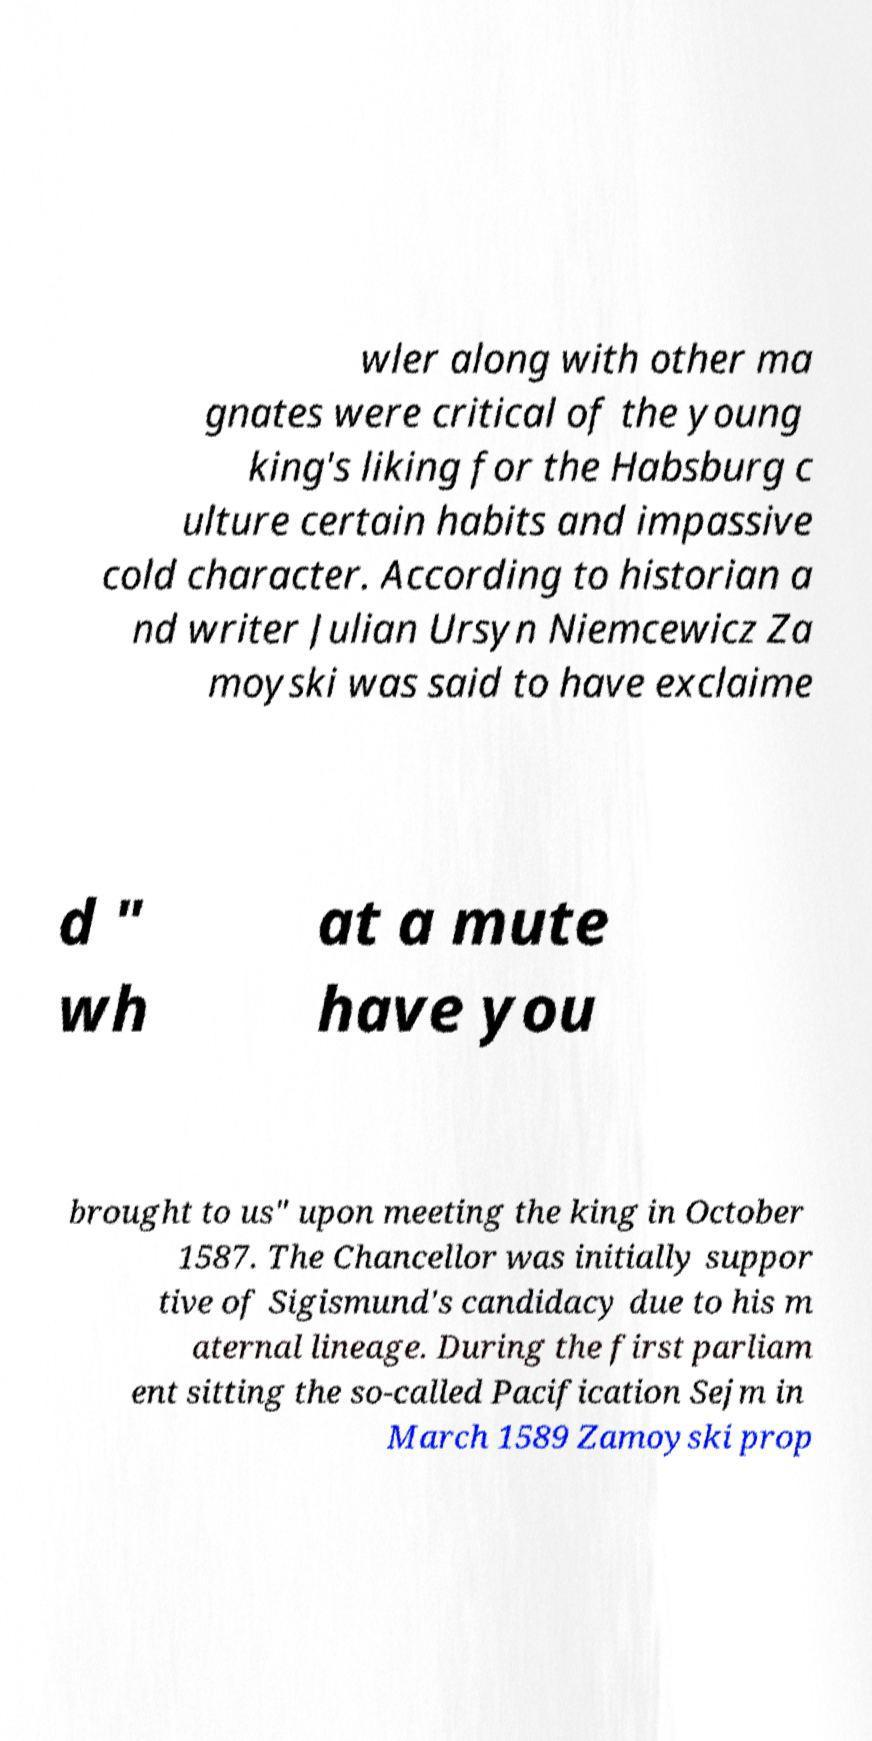Please read and relay the text visible in this image. What does it say? wler along with other ma gnates were critical of the young king's liking for the Habsburg c ulture certain habits and impassive cold character. According to historian a nd writer Julian Ursyn Niemcewicz Za moyski was said to have exclaime d " wh at a mute have you brought to us" upon meeting the king in October 1587. The Chancellor was initially suppor tive of Sigismund's candidacy due to his m aternal lineage. During the first parliam ent sitting the so-called Pacification Sejm in March 1589 Zamoyski prop 